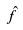<formula> <loc_0><loc_0><loc_500><loc_500>\hat { f }</formula> 